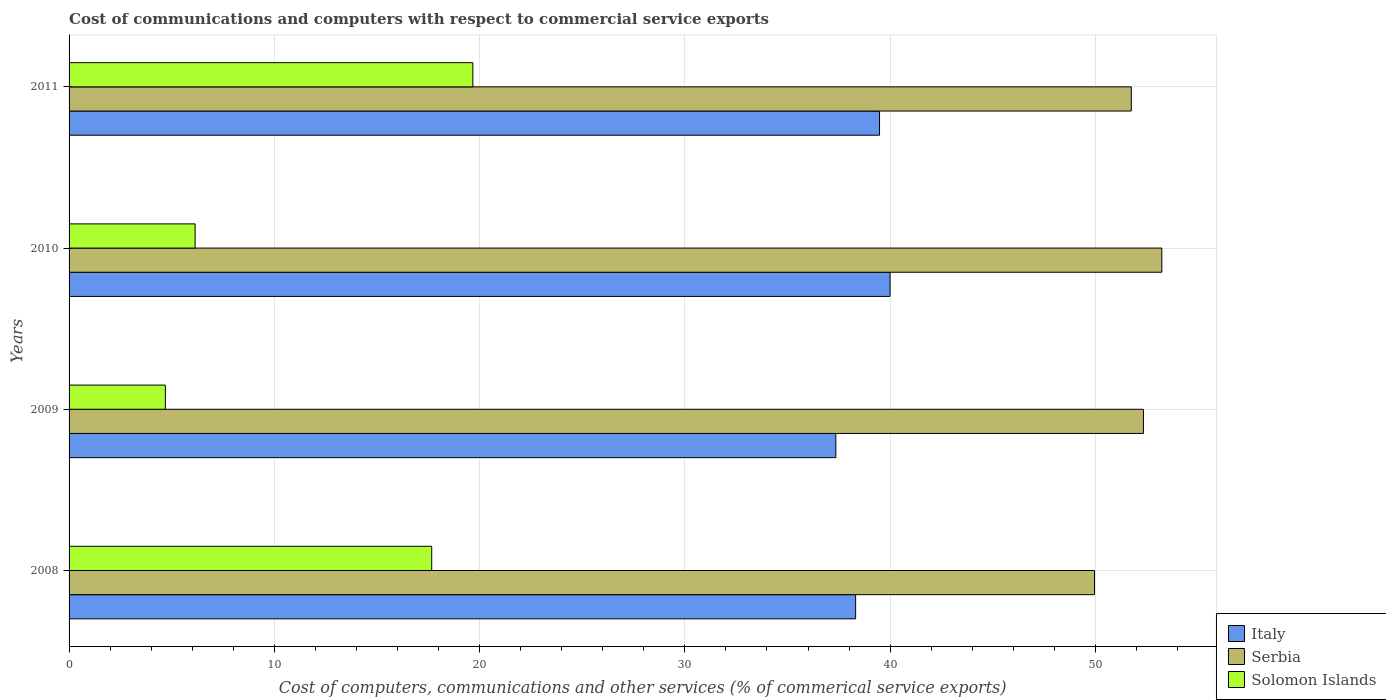Are the number of bars per tick equal to the number of legend labels?
Your response must be concise. Yes. Are the number of bars on each tick of the Y-axis equal?
Make the answer very short. Yes. What is the label of the 4th group of bars from the top?
Your answer should be very brief. 2008. In how many cases, is the number of bars for a given year not equal to the number of legend labels?
Your response must be concise. 0. What is the cost of communications and computers in Serbia in 2009?
Offer a terse response. 52.34. Across all years, what is the maximum cost of communications and computers in Solomon Islands?
Give a very brief answer. 19.67. Across all years, what is the minimum cost of communications and computers in Serbia?
Your answer should be very brief. 49.96. In which year was the cost of communications and computers in Italy minimum?
Provide a short and direct response. 2009. What is the total cost of communications and computers in Serbia in the graph?
Your response must be concise. 207.28. What is the difference between the cost of communications and computers in Italy in 2009 and that in 2011?
Your answer should be very brief. -2.13. What is the difference between the cost of communications and computers in Serbia in 2010 and the cost of communications and computers in Italy in 2008?
Ensure brevity in your answer.  14.92. What is the average cost of communications and computers in Serbia per year?
Offer a very short reply. 51.82. In the year 2008, what is the difference between the cost of communications and computers in Serbia and cost of communications and computers in Italy?
Offer a terse response. 11.64. What is the ratio of the cost of communications and computers in Solomon Islands in 2008 to that in 2010?
Your answer should be compact. 2.88. Is the cost of communications and computers in Italy in 2009 less than that in 2011?
Ensure brevity in your answer.  Yes. Is the difference between the cost of communications and computers in Serbia in 2009 and 2010 greater than the difference between the cost of communications and computers in Italy in 2009 and 2010?
Keep it short and to the point. Yes. What is the difference between the highest and the second highest cost of communications and computers in Serbia?
Your answer should be very brief. 0.9. What is the difference between the highest and the lowest cost of communications and computers in Serbia?
Your answer should be very brief. 3.28. Is the sum of the cost of communications and computers in Serbia in 2008 and 2010 greater than the maximum cost of communications and computers in Solomon Islands across all years?
Offer a terse response. Yes. What does the 1st bar from the top in 2008 represents?
Give a very brief answer. Solomon Islands. What does the 2nd bar from the bottom in 2008 represents?
Give a very brief answer. Serbia. How many bars are there?
Provide a succinct answer. 12. How many years are there in the graph?
Provide a short and direct response. 4. What is the difference between two consecutive major ticks on the X-axis?
Offer a very short reply. 10. Are the values on the major ticks of X-axis written in scientific E-notation?
Keep it short and to the point. No. Does the graph contain any zero values?
Your answer should be very brief. No. Does the graph contain grids?
Keep it short and to the point. Yes. Where does the legend appear in the graph?
Give a very brief answer. Bottom right. How are the legend labels stacked?
Make the answer very short. Vertical. What is the title of the graph?
Keep it short and to the point. Cost of communications and computers with respect to commercial service exports. What is the label or title of the X-axis?
Keep it short and to the point. Cost of computers, communications and other services (% of commerical service exports). What is the Cost of computers, communications and other services (% of commerical service exports) of Italy in 2008?
Your answer should be compact. 38.32. What is the Cost of computers, communications and other services (% of commerical service exports) in Serbia in 2008?
Make the answer very short. 49.96. What is the Cost of computers, communications and other services (% of commerical service exports) in Solomon Islands in 2008?
Give a very brief answer. 17.67. What is the Cost of computers, communications and other services (% of commerical service exports) in Italy in 2009?
Offer a very short reply. 37.35. What is the Cost of computers, communications and other services (% of commerical service exports) of Serbia in 2009?
Offer a very short reply. 52.34. What is the Cost of computers, communications and other services (% of commerical service exports) in Solomon Islands in 2009?
Ensure brevity in your answer.  4.69. What is the Cost of computers, communications and other services (% of commerical service exports) in Italy in 2010?
Your answer should be very brief. 40. What is the Cost of computers, communications and other services (% of commerical service exports) in Serbia in 2010?
Offer a very short reply. 53.23. What is the Cost of computers, communications and other services (% of commerical service exports) of Solomon Islands in 2010?
Make the answer very short. 6.14. What is the Cost of computers, communications and other services (% of commerical service exports) in Italy in 2011?
Provide a short and direct response. 39.48. What is the Cost of computers, communications and other services (% of commerical service exports) in Serbia in 2011?
Your response must be concise. 51.75. What is the Cost of computers, communications and other services (% of commerical service exports) in Solomon Islands in 2011?
Your answer should be compact. 19.67. Across all years, what is the maximum Cost of computers, communications and other services (% of commerical service exports) in Italy?
Ensure brevity in your answer.  40. Across all years, what is the maximum Cost of computers, communications and other services (% of commerical service exports) of Serbia?
Your response must be concise. 53.23. Across all years, what is the maximum Cost of computers, communications and other services (% of commerical service exports) of Solomon Islands?
Offer a terse response. 19.67. Across all years, what is the minimum Cost of computers, communications and other services (% of commerical service exports) of Italy?
Provide a succinct answer. 37.35. Across all years, what is the minimum Cost of computers, communications and other services (% of commerical service exports) of Serbia?
Offer a very short reply. 49.96. Across all years, what is the minimum Cost of computers, communications and other services (% of commerical service exports) of Solomon Islands?
Provide a short and direct response. 4.69. What is the total Cost of computers, communications and other services (% of commerical service exports) in Italy in the graph?
Offer a very short reply. 155.15. What is the total Cost of computers, communications and other services (% of commerical service exports) of Serbia in the graph?
Ensure brevity in your answer.  207.28. What is the total Cost of computers, communications and other services (% of commerical service exports) in Solomon Islands in the graph?
Ensure brevity in your answer.  48.17. What is the difference between the Cost of computers, communications and other services (% of commerical service exports) of Italy in 2008 and that in 2009?
Ensure brevity in your answer.  0.97. What is the difference between the Cost of computers, communications and other services (% of commerical service exports) in Serbia in 2008 and that in 2009?
Give a very brief answer. -2.38. What is the difference between the Cost of computers, communications and other services (% of commerical service exports) of Solomon Islands in 2008 and that in 2009?
Your response must be concise. 12.98. What is the difference between the Cost of computers, communications and other services (% of commerical service exports) in Italy in 2008 and that in 2010?
Your response must be concise. -1.68. What is the difference between the Cost of computers, communications and other services (% of commerical service exports) of Serbia in 2008 and that in 2010?
Offer a very short reply. -3.28. What is the difference between the Cost of computers, communications and other services (% of commerical service exports) of Solomon Islands in 2008 and that in 2010?
Offer a very short reply. 11.53. What is the difference between the Cost of computers, communications and other services (% of commerical service exports) in Italy in 2008 and that in 2011?
Offer a very short reply. -1.16. What is the difference between the Cost of computers, communications and other services (% of commerical service exports) of Serbia in 2008 and that in 2011?
Your answer should be compact. -1.79. What is the difference between the Cost of computers, communications and other services (% of commerical service exports) of Solomon Islands in 2008 and that in 2011?
Your response must be concise. -2. What is the difference between the Cost of computers, communications and other services (% of commerical service exports) of Italy in 2009 and that in 2010?
Give a very brief answer. -2.64. What is the difference between the Cost of computers, communications and other services (% of commerical service exports) of Serbia in 2009 and that in 2010?
Offer a very short reply. -0.9. What is the difference between the Cost of computers, communications and other services (% of commerical service exports) of Solomon Islands in 2009 and that in 2010?
Give a very brief answer. -1.45. What is the difference between the Cost of computers, communications and other services (% of commerical service exports) of Italy in 2009 and that in 2011?
Provide a short and direct response. -2.13. What is the difference between the Cost of computers, communications and other services (% of commerical service exports) in Serbia in 2009 and that in 2011?
Ensure brevity in your answer.  0.59. What is the difference between the Cost of computers, communications and other services (% of commerical service exports) of Solomon Islands in 2009 and that in 2011?
Offer a terse response. -14.98. What is the difference between the Cost of computers, communications and other services (% of commerical service exports) in Italy in 2010 and that in 2011?
Your response must be concise. 0.51. What is the difference between the Cost of computers, communications and other services (% of commerical service exports) in Serbia in 2010 and that in 2011?
Keep it short and to the point. 1.49. What is the difference between the Cost of computers, communications and other services (% of commerical service exports) in Solomon Islands in 2010 and that in 2011?
Ensure brevity in your answer.  -13.53. What is the difference between the Cost of computers, communications and other services (% of commerical service exports) in Italy in 2008 and the Cost of computers, communications and other services (% of commerical service exports) in Serbia in 2009?
Ensure brevity in your answer.  -14.02. What is the difference between the Cost of computers, communications and other services (% of commerical service exports) in Italy in 2008 and the Cost of computers, communications and other services (% of commerical service exports) in Solomon Islands in 2009?
Offer a terse response. 33.63. What is the difference between the Cost of computers, communications and other services (% of commerical service exports) in Serbia in 2008 and the Cost of computers, communications and other services (% of commerical service exports) in Solomon Islands in 2009?
Offer a terse response. 45.27. What is the difference between the Cost of computers, communications and other services (% of commerical service exports) in Italy in 2008 and the Cost of computers, communications and other services (% of commerical service exports) in Serbia in 2010?
Provide a short and direct response. -14.92. What is the difference between the Cost of computers, communications and other services (% of commerical service exports) of Italy in 2008 and the Cost of computers, communications and other services (% of commerical service exports) of Solomon Islands in 2010?
Your answer should be very brief. 32.18. What is the difference between the Cost of computers, communications and other services (% of commerical service exports) of Serbia in 2008 and the Cost of computers, communications and other services (% of commerical service exports) of Solomon Islands in 2010?
Offer a terse response. 43.81. What is the difference between the Cost of computers, communications and other services (% of commerical service exports) of Italy in 2008 and the Cost of computers, communications and other services (% of commerical service exports) of Serbia in 2011?
Provide a succinct answer. -13.43. What is the difference between the Cost of computers, communications and other services (% of commerical service exports) in Italy in 2008 and the Cost of computers, communications and other services (% of commerical service exports) in Solomon Islands in 2011?
Offer a terse response. 18.65. What is the difference between the Cost of computers, communications and other services (% of commerical service exports) of Serbia in 2008 and the Cost of computers, communications and other services (% of commerical service exports) of Solomon Islands in 2011?
Offer a terse response. 30.29. What is the difference between the Cost of computers, communications and other services (% of commerical service exports) in Italy in 2009 and the Cost of computers, communications and other services (% of commerical service exports) in Serbia in 2010?
Make the answer very short. -15.88. What is the difference between the Cost of computers, communications and other services (% of commerical service exports) of Italy in 2009 and the Cost of computers, communications and other services (% of commerical service exports) of Solomon Islands in 2010?
Keep it short and to the point. 31.21. What is the difference between the Cost of computers, communications and other services (% of commerical service exports) of Serbia in 2009 and the Cost of computers, communications and other services (% of commerical service exports) of Solomon Islands in 2010?
Offer a very short reply. 46.2. What is the difference between the Cost of computers, communications and other services (% of commerical service exports) of Italy in 2009 and the Cost of computers, communications and other services (% of commerical service exports) of Serbia in 2011?
Make the answer very short. -14.4. What is the difference between the Cost of computers, communications and other services (% of commerical service exports) in Italy in 2009 and the Cost of computers, communications and other services (% of commerical service exports) in Solomon Islands in 2011?
Your answer should be very brief. 17.68. What is the difference between the Cost of computers, communications and other services (% of commerical service exports) in Serbia in 2009 and the Cost of computers, communications and other services (% of commerical service exports) in Solomon Islands in 2011?
Offer a terse response. 32.67. What is the difference between the Cost of computers, communications and other services (% of commerical service exports) of Italy in 2010 and the Cost of computers, communications and other services (% of commerical service exports) of Serbia in 2011?
Make the answer very short. -11.75. What is the difference between the Cost of computers, communications and other services (% of commerical service exports) of Italy in 2010 and the Cost of computers, communications and other services (% of commerical service exports) of Solomon Islands in 2011?
Offer a terse response. 20.33. What is the difference between the Cost of computers, communications and other services (% of commerical service exports) in Serbia in 2010 and the Cost of computers, communications and other services (% of commerical service exports) in Solomon Islands in 2011?
Your answer should be compact. 33.56. What is the average Cost of computers, communications and other services (% of commerical service exports) of Italy per year?
Make the answer very short. 38.79. What is the average Cost of computers, communications and other services (% of commerical service exports) in Serbia per year?
Give a very brief answer. 51.82. What is the average Cost of computers, communications and other services (% of commerical service exports) of Solomon Islands per year?
Keep it short and to the point. 12.04. In the year 2008, what is the difference between the Cost of computers, communications and other services (% of commerical service exports) of Italy and Cost of computers, communications and other services (% of commerical service exports) of Serbia?
Provide a short and direct response. -11.64. In the year 2008, what is the difference between the Cost of computers, communications and other services (% of commerical service exports) of Italy and Cost of computers, communications and other services (% of commerical service exports) of Solomon Islands?
Offer a very short reply. 20.65. In the year 2008, what is the difference between the Cost of computers, communications and other services (% of commerical service exports) of Serbia and Cost of computers, communications and other services (% of commerical service exports) of Solomon Islands?
Keep it short and to the point. 32.29. In the year 2009, what is the difference between the Cost of computers, communications and other services (% of commerical service exports) of Italy and Cost of computers, communications and other services (% of commerical service exports) of Serbia?
Provide a short and direct response. -14.99. In the year 2009, what is the difference between the Cost of computers, communications and other services (% of commerical service exports) of Italy and Cost of computers, communications and other services (% of commerical service exports) of Solomon Islands?
Your answer should be very brief. 32.66. In the year 2009, what is the difference between the Cost of computers, communications and other services (% of commerical service exports) in Serbia and Cost of computers, communications and other services (% of commerical service exports) in Solomon Islands?
Your answer should be compact. 47.65. In the year 2010, what is the difference between the Cost of computers, communications and other services (% of commerical service exports) of Italy and Cost of computers, communications and other services (% of commerical service exports) of Serbia?
Offer a terse response. -13.24. In the year 2010, what is the difference between the Cost of computers, communications and other services (% of commerical service exports) in Italy and Cost of computers, communications and other services (% of commerical service exports) in Solomon Islands?
Keep it short and to the point. 33.85. In the year 2010, what is the difference between the Cost of computers, communications and other services (% of commerical service exports) of Serbia and Cost of computers, communications and other services (% of commerical service exports) of Solomon Islands?
Your answer should be compact. 47.09. In the year 2011, what is the difference between the Cost of computers, communications and other services (% of commerical service exports) of Italy and Cost of computers, communications and other services (% of commerical service exports) of Serbia?
Offer a very short reply. -12.27. In the year 2011, what is the difference between the Cost of computers, communications and other services (% of commerical service exports) in Italy and Cost of computers, communications and other services (% of commerical service exports) in Solomon Islands?
Ensure brevity in your answer.  19.81. In the year 2011, what is the difference between the Cost of computers, communications and other services (% of commerical service exports) in Serbia and Cost of computers, communications and other services (% of commerical service exports) in Solomon Islands?
Offer a very short reply. 32.08. What is the ratio of the Cost of computers, communications and other services (% of commerical service exports) in Italy in 2008 to that in 2009?
Make the answer very short. 1.03. What is the ratio of the Cost of computers, communications and other services (% of commerical service exports) in Serbia in 2008 to that in 2009?
Ensure brevity in your answer.  0.95. What is the ratio of the Cost of computers, communications and other services (% of commerical service exports) of Solomon Islands in 2008 to that in 2009?
Keep it short and to the point. 3.77. What is the ratio of the Cost of computers, communications and other services (% of commerical service exports) in Italy in 2008 to that in 2010?
Offer a terse response. 0.96. What is the ratio of the Cost of computers, communications and other services (% of commerical service exports) of Serbia in 2008 to that in 2010?
Provide a short and direct response. 0.94. What is the ratio of the Cost of computers, communications and other services (% of commerical service exports) in Solomon Islands in 2008 to that in 2010?
Offer a very short reply. 2.88. What is the ratio of the Cost of computers, communications and other services (% of commerical service exports) of Italy in 2008 to that in 2011?
Provide a succinct answer. 0.97. What is the ratio of the Cost of computers, communications and other services (% of commerical service exports) of Serbia in 2008 to that in 2011?
Offer a terse response. 0.97. What is the ratio of the Cost of computers, communications and other services (% of commerical service exports) of Solomon Islands in 2008 to that in 2011?
Make the answer very short. 0.9. What is the ratio of the Cost of computers, communications and other services (% of commerical service exports) of Italy in 2009 to that in 2010?
Keep it short and to the point. 0.93. What is the ratio of the Cost of computers, communications and other services (% of commerical service exports) in Serbia in 2009 to that in 2010?
Your answer should be compact. 0.98. What is the ratio of the Cost of computers, communications and other services (% of commerical service exports) in Solomon Islands in 2009 to that in 2010?
Provide a succinct answer. 0.76. What is the ratio of the Cost of computers, communications and other services (% of commerical service exports) in Italy in 2009 to that in 2011?
Your answer should be compact. 0.95. What is the ratio of the Cost of computers, communications and other services (% of commerical service exports) in Serbia in 2009 to that in 2011?
Provide a succinct answer. 1.01. What is the ratio of the Cost of computers, communications and other services (% of commerical service exports) of Solomon Islands in 2009 to that in 2011?
Your response must be concise. 0.24. What is the ratio of the Cost of computers, communications and other services (% of commerical service exports) in Italy in 2010 to that in 2011?
Offer a terse response. 1.01. What is the ratio of the Cost of computers, communications and other services (% of commerical service exports) of Serbia in 2010 to that in 2011?
Give a very brief answer. 1.03. What is the ratio of the Cost of computers, communications and other services (% of commerical service exports) in Solomon Islands in 2010 to that in 2011?
Give a very brief answer. 0.31. What is the difference between the highest and the second highest Cost of computers, communications and other services (% of commerical service exports) of Italy?
Keep it short and to the point. 0.51. What is the difference between the highest and the second highest Cost of computers, communications and other services (% of commerical service exports) of Serbia?
Ensure brevity in your answer.  0.9. What is the difference between the highest and the second highest Cost of computers, communications and other services (% of commerical service exports) in Solomon Islands?
Keep it short and to the point. 2. What is the difference between the highest and the lowest Cost of computers, communications and other services (% of commerical service exports) in Italy?
Provide a short and direct response. 2.64. What is the difference between the highest and the lowest Cost of computers, communications and other services (% of commerical service exports) in Serbia?
Ensure brevity in your answer.  3.28. What is the difference between the highest and the lowest Cost of computers, communications and other services (% of commerical service exports) of Solomon Islands?
Provide a succinct answer. 14.98. 